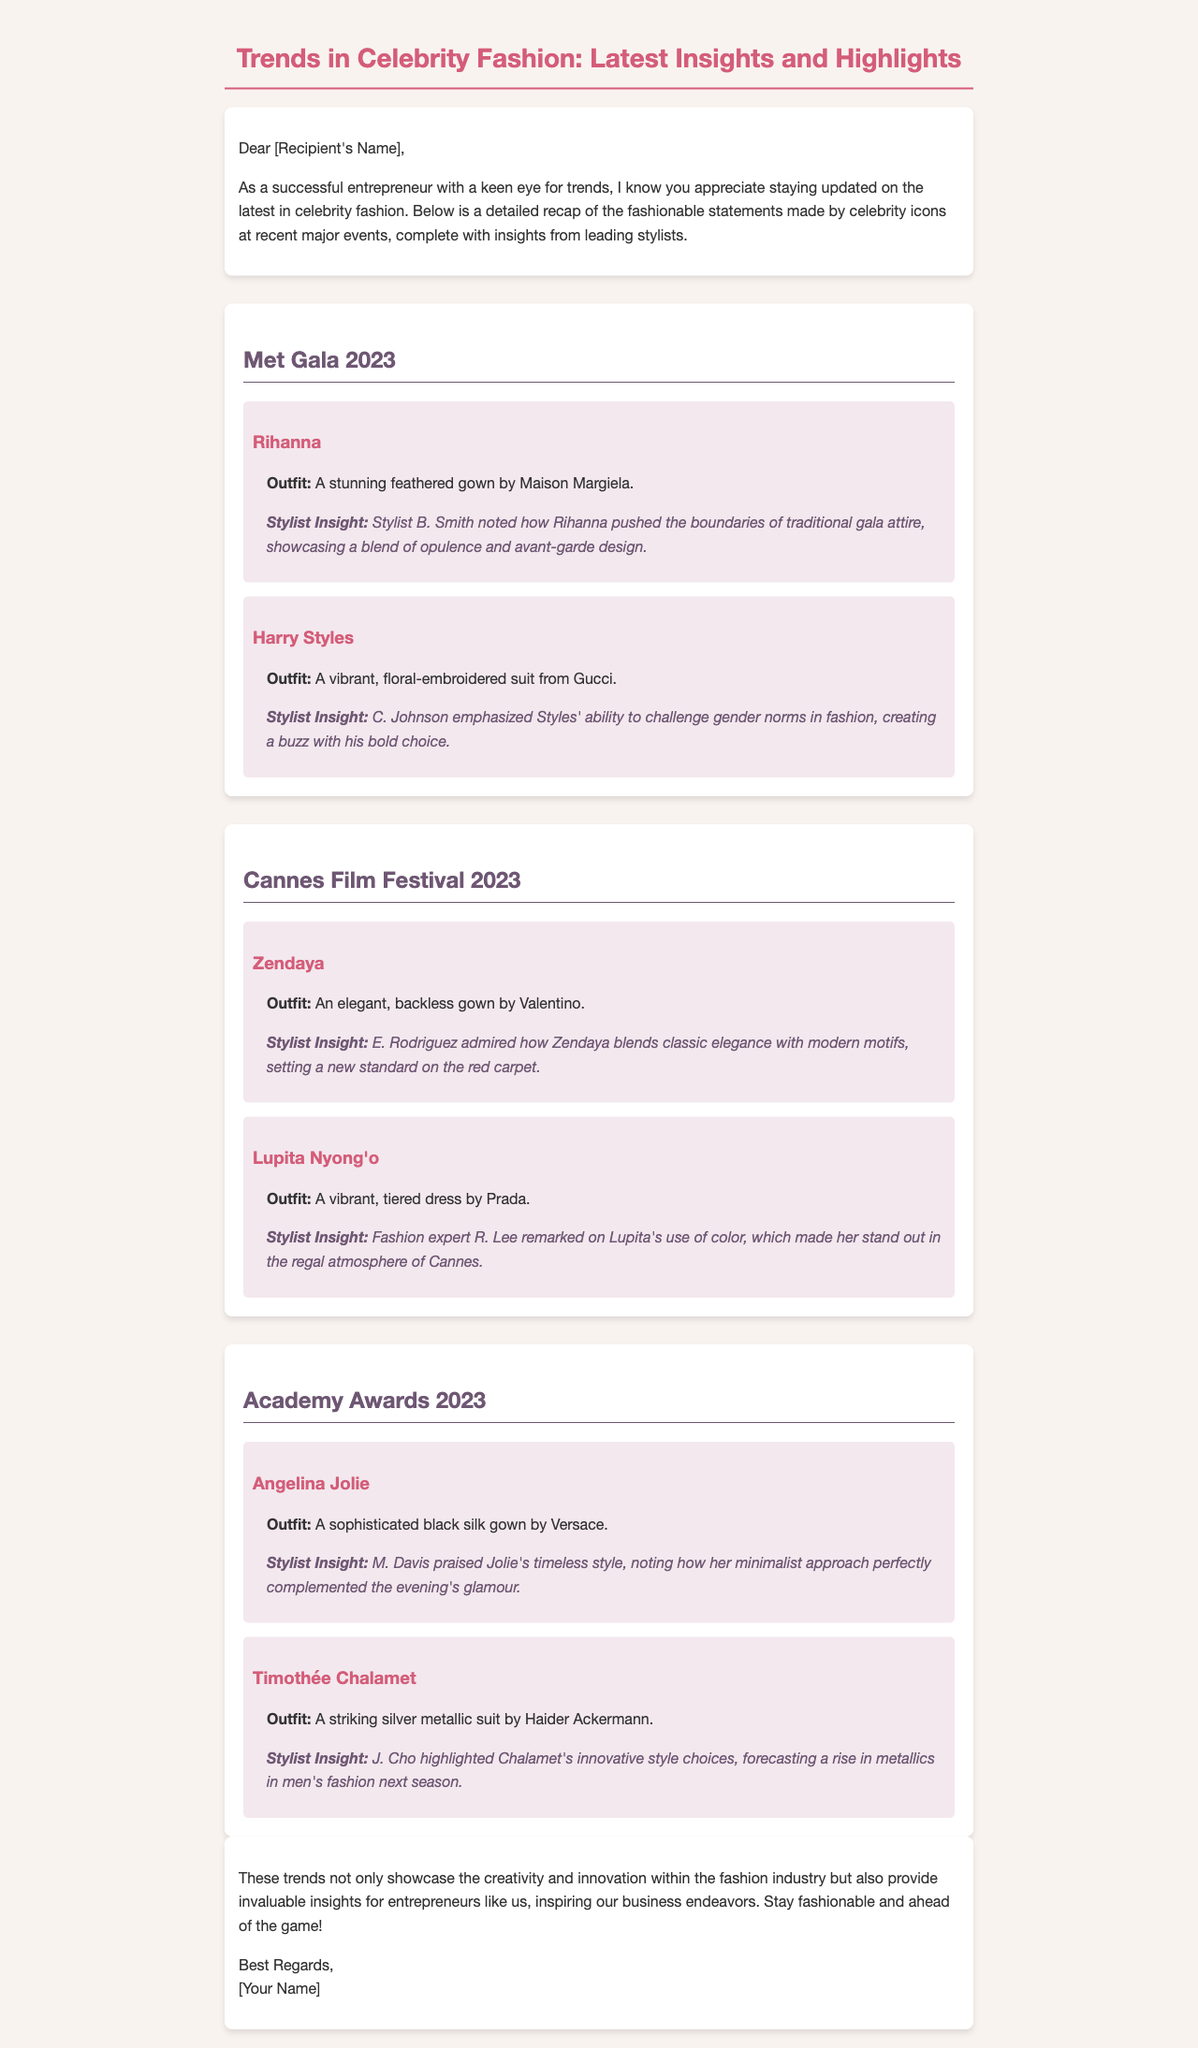What was Rihanna's outfit at the Met Gala 2023? Rihanna wore a stunning feathered gown by Maison Margiela at the Met Gala.
Answer: A stunning feathered gown by Maison Margiela Who styled Harry Styles' outfit? The insight notes that stylist C. Johnson emphasized Styles' bold choice.
Answer: C. Johnson What type of gown did Zendaya wear at the Cannes Film Festival 2023? Zendaya wore an elegant, backless gown by Valentino at the Cannes Film Festival.
Answer: An elegant, backless gown by Valentino Which celebrity wore a silk gown at the Academy Awards 2023? Angelina Jolie wore a sophisticated black silk gown by Versace at the Academy Awards.
Answer: Angelina Jolie What color was Lupita Nyong'o's dress at the Cannes Film Festival 2023? The insight on Lupita remarks about her vibrant tiered dress.
Answer: Vibrant What fashion trend did Timothée Chalamet's outfit forecast? The document mentions Chalamet's innovative style choices forecast a rise in metallics in men's fashion.
Answer: A rise in metallics What event featured the outfits discussed in the email? The email recaps fashion showcased at major events, specifically listing Met Gala, Cannes Film Festival, and Academy Awards.
Answer: Met Gala, Cannes Film Festival, and Academy Awards What does the closing paragraph emphasize for entrepreneurs? The closing paragraph inspires entrepreneurs by showcasing creativity and innovation in fashion.
Answer: Creativity and innovation What major stylist insight did E. Rodriguez provide about Zendaya? E. Rodriguez admired how Zendaya blends classic elegance with modern motifs.
Answer: Blends classic elegance with modern motifs 